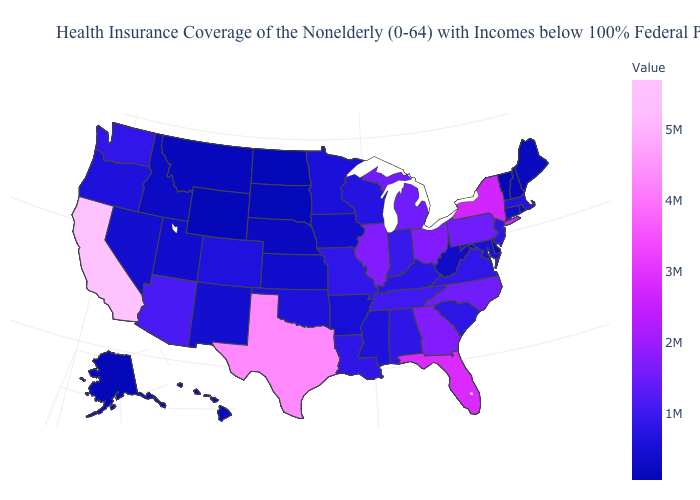Among the states that border Minnesota , does South Dakota have the lowest value?
Give a very brief answer. No. Among the states that border Tennessee , does Virginia have the highest value?
Write a very short answer. No. Among the states that border Illinois , does Missouri have the lowest value?
Quick response, please. No. Among the states that border Arkansas , which have the lowest value?
Short answer required. Oklahoma. Does New York have the highest value in the Northeast?
Write a very short answer. Yes. Which states have the lowest value in the MidWest?
Short answer required. North Dakota. 